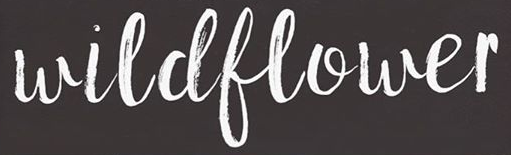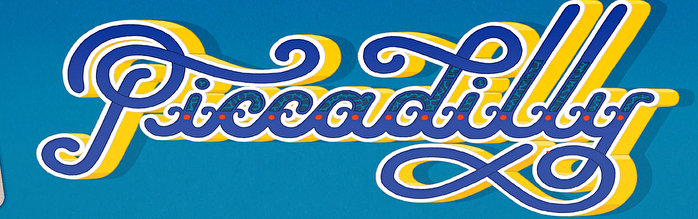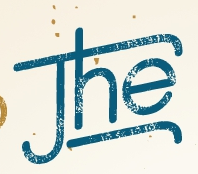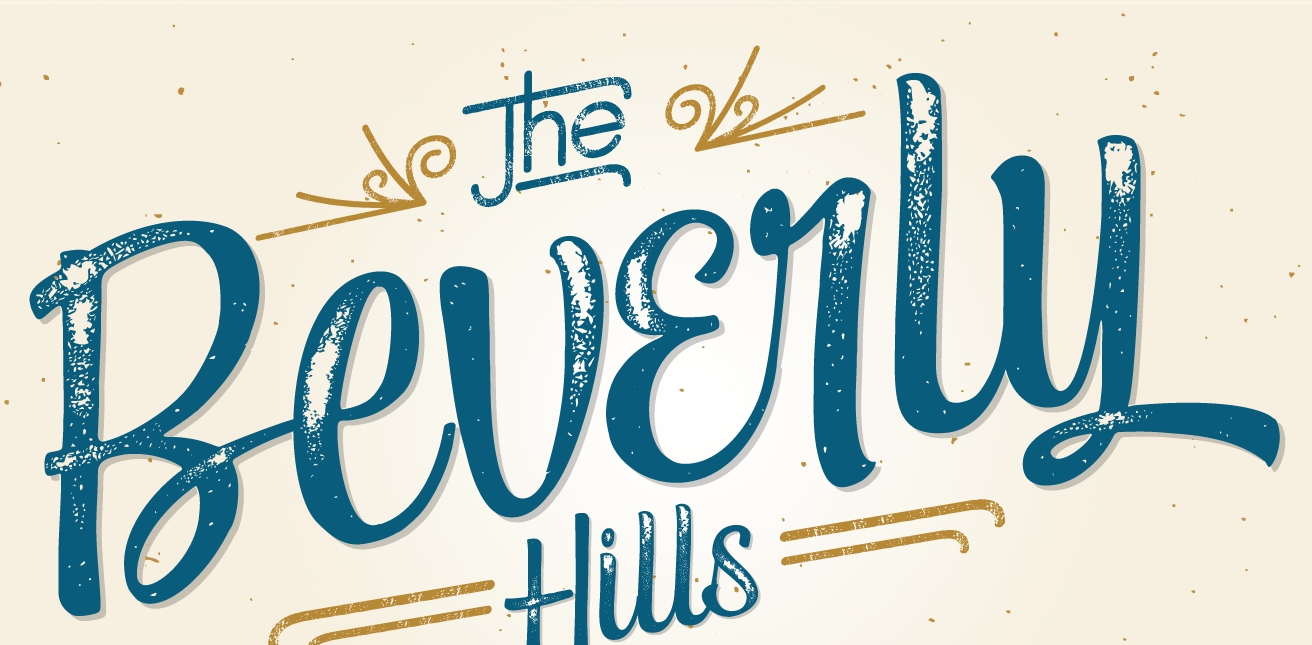What text appears in these images from left to right, separated by a semicolon? wildflower; Piccadilly; The; Beverly 